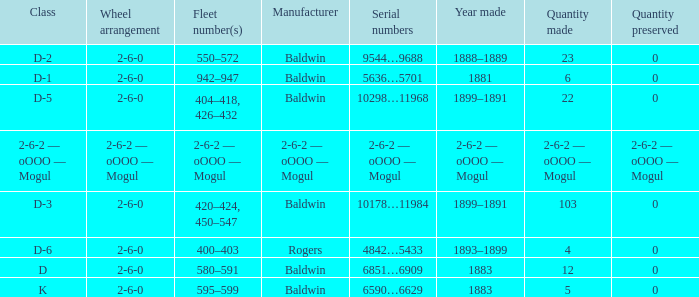What is the year made when the manufacturer is 2-6-2 — oooo — mogul? 2-6-2 — oOOO — Mogul. 